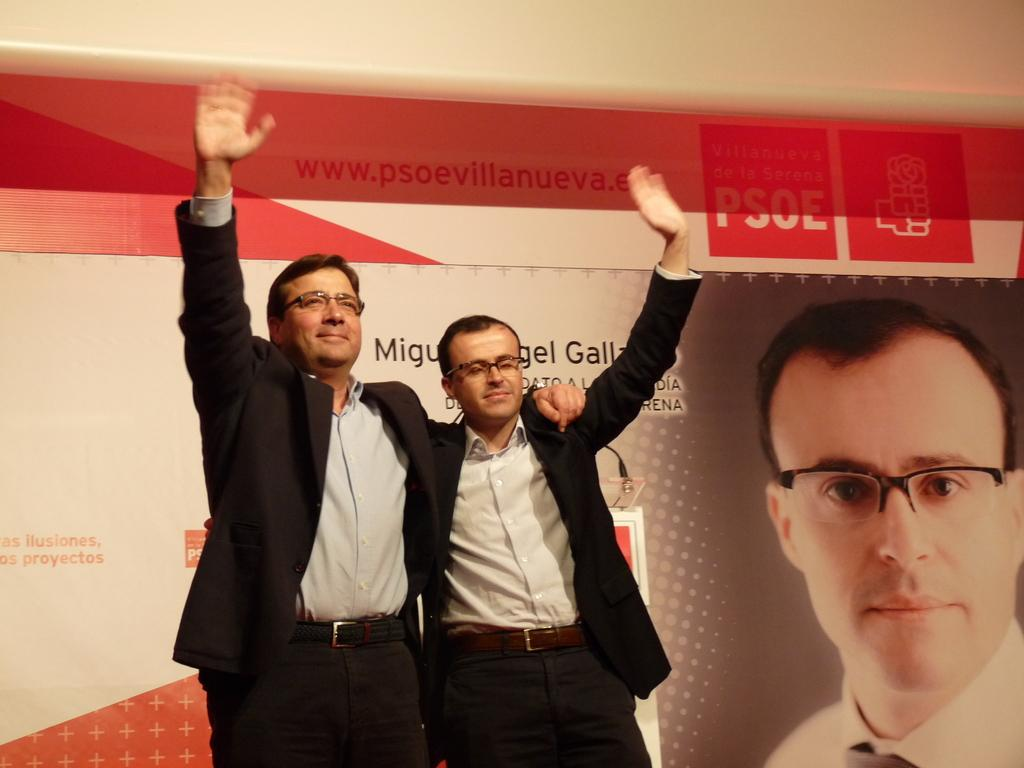How many people are in the center of the image? There are two men in the center of the image. What is located behind the men? There is a banner behind the men. What type of fish can be seen cooking on the stove in the image? There is no fish or stove present in the image; it features two men and a banner. How many basketballs are visible in the image? There are no basketballs present in the image. 